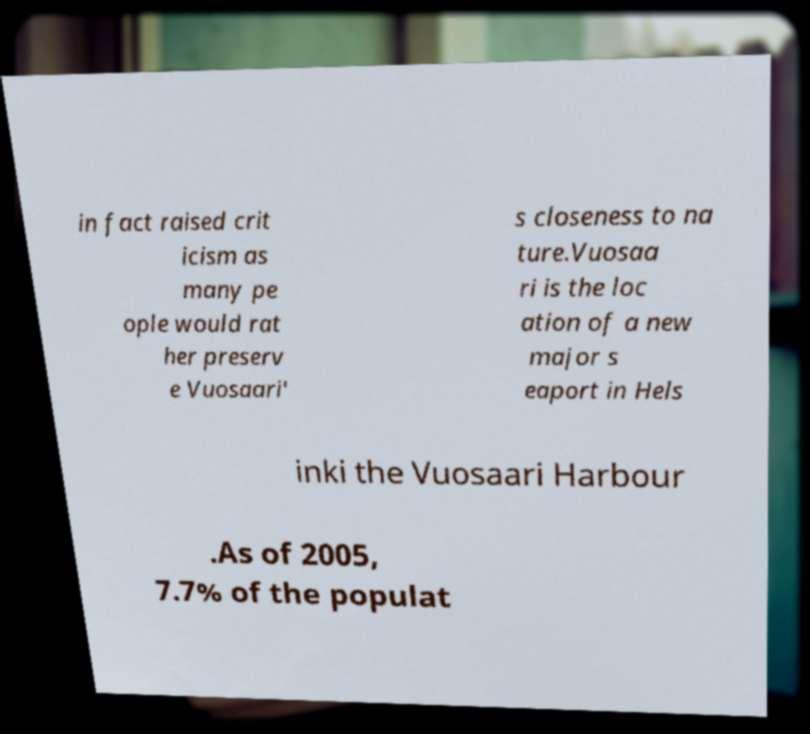Please identify and transcribe the text found in this image. in fact raised crit icism as many pe ople would rat her preserv e Vuosaari' s closeness to na ture.Vuosaa ri is the loc ation of a new major s eaport in Hels inki the Vuosaari Harbour .As of 2005, 7.7% of the populat 